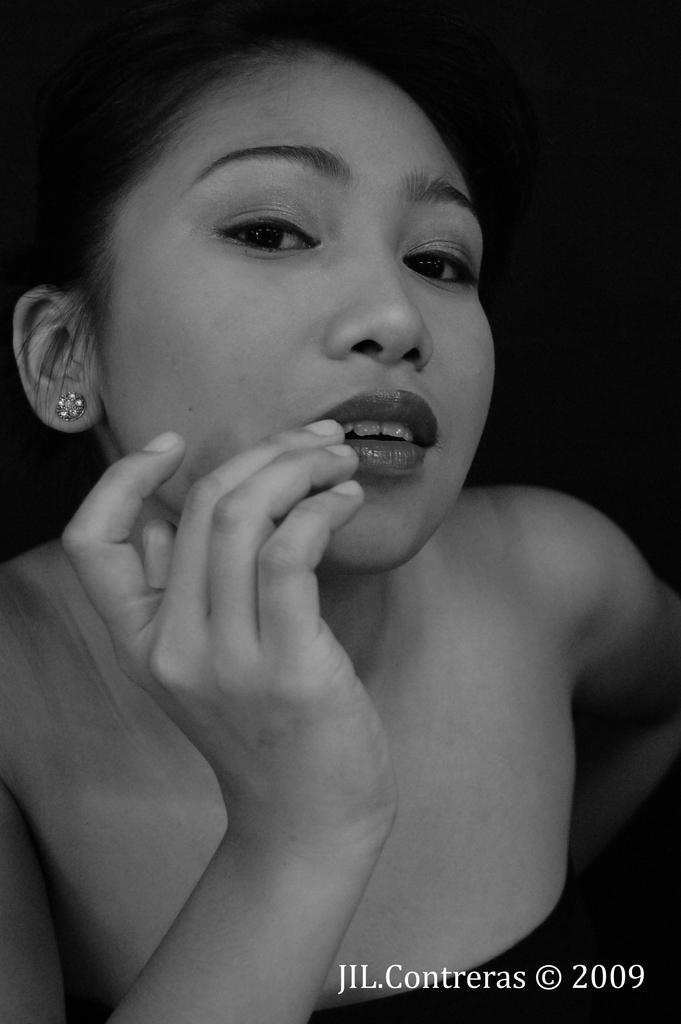What is the color scheme of the image? The image is black and white. Can you describe the main subject of the image? There is a person in the image. Where is the text located in the image? The text is in the bottom right corner of the image. What type of theory is being explained in the image? There is no theory being explained in the image, as it only contains a person and text in the bottom right corner. Can you tell me the punchline of the joke in the image? There is no joke present in the image; it is a black and white image with a person and text in the bottom right corner. 